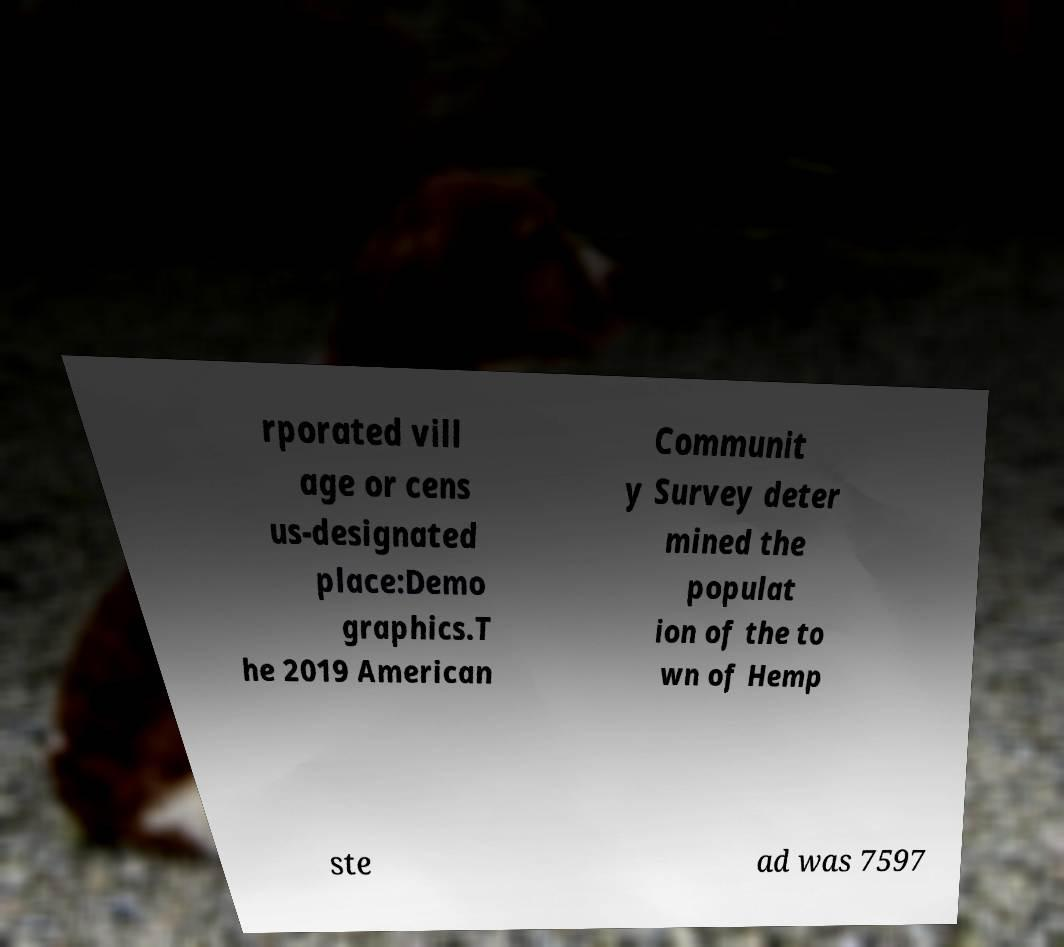Please identify and transcribe the text found in this image. rporated vill age or cens us-designated place:Demo graphics.T he 2019 American Communit y Survey deter mined the populat ion of the to wn of Hemp ste ad was 7597 